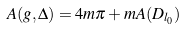Convert formula to latex. <formula><loc_0><loc_0><loc_500><loc_500>A ( g , \Delta ) = 4 m \pi + m A ( D _ { l _ { 0 } } )</formula> 